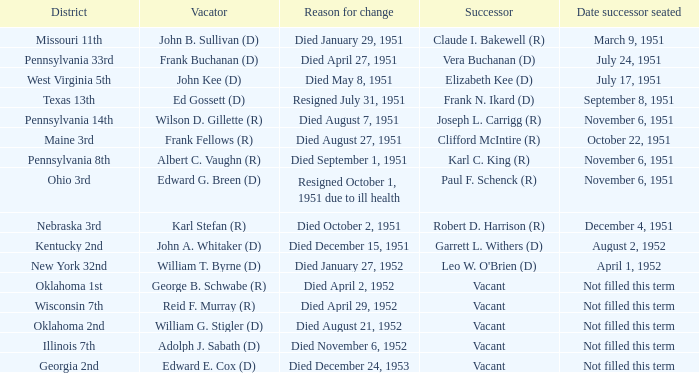How many vacators were in the Pennsylvania 33rd district? 1.0. 